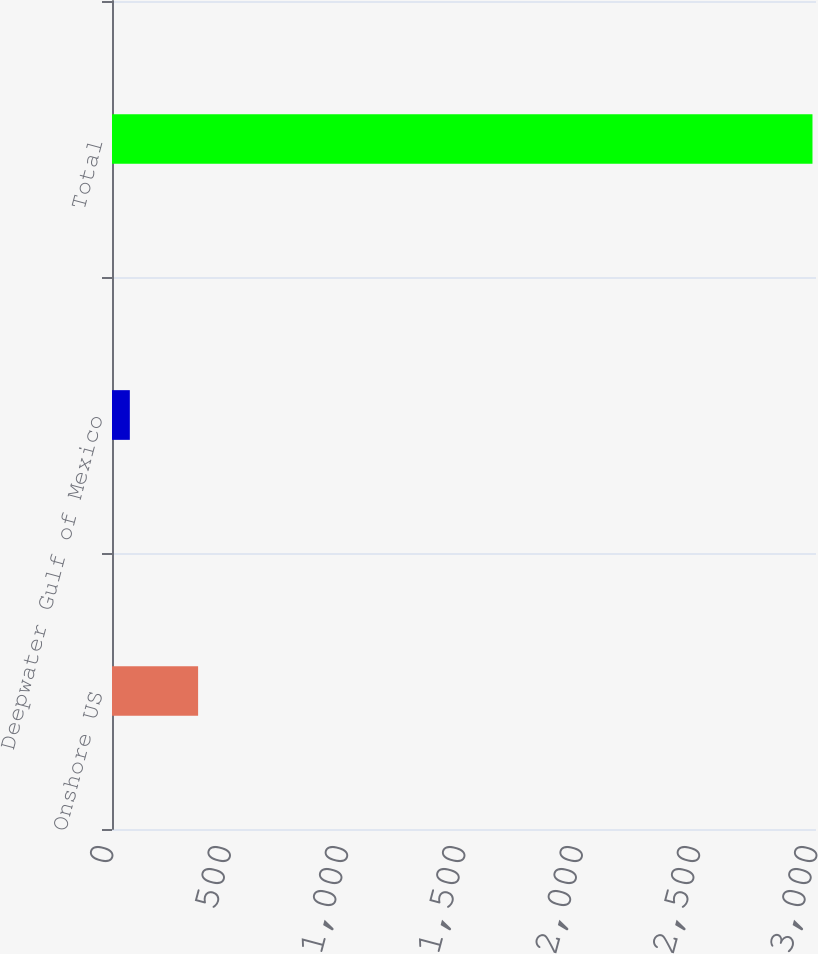Convert chart to OTSL. <chart><loc_0><loc_0><loc_500><loc_500><bar_chart><fcel>Onshore US<fcel>Deepwater Gulf of Mexico<fcel>Total<nl><fcel>366.9<fcel>76<fcel>2985<nl></chart> 